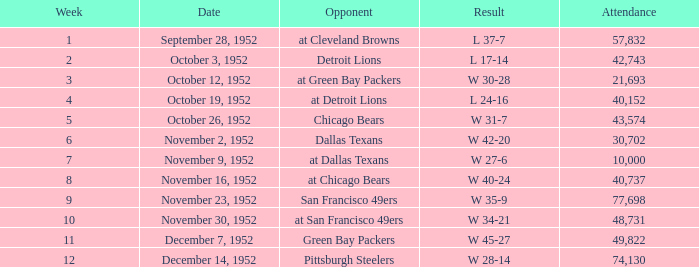When is the concluding week that has a score of w 34-21? 10.0. 